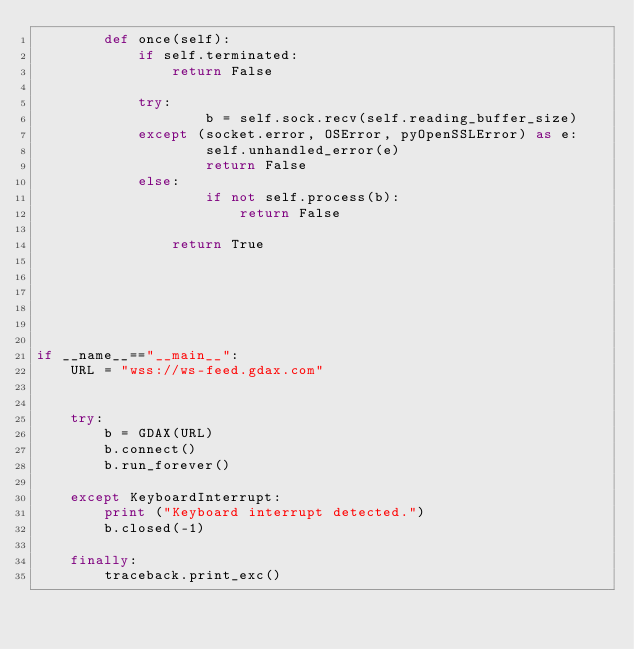<code> <loc_0><loc_0><loc_500><loc_500><_Python_>        def once(self):
        	if self.terminated:
        		return False

            try:
                    b = self.sock.recv(self.reading_buffer_size)
            except (socket.error, OSError, pyOpenSSLError) as e:
                    self.unhandled_error(e)
                    return False
            else:
                    if not self.process(b):
                    	return False

                return True


		

			

if __name__=="__main__":
	URL = "wss://ws-feed.gdax.com"


	try:
		b = GDAX(URL)
		b.connect()
		b.run_forever()

	except KeyboardInterrupt:
		print ("Keyboard interrupt detected.")
		b.closed(-1)

	finally:
		traceback.print_exc()
</code> 